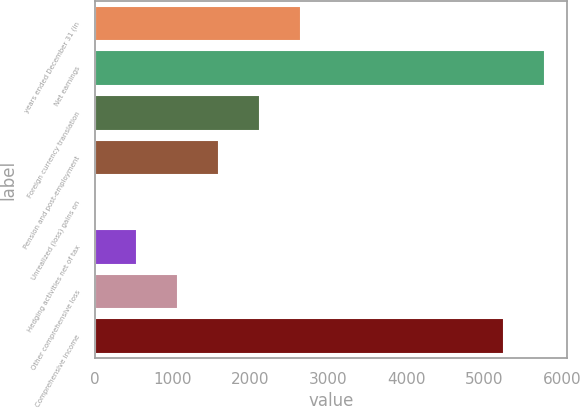Convert chart. <chart><loc_0><loc_0><loc_500><loc_500><bar_chart><fcel>years ended December 31 (in<fcel>Net earnings<fcel>Foreign currency translation<fcel>Pension and post-employment<fcel>Unrealized (loss) gains on<fcel>Hedging activities net of tax<fcel>Other comprehensive loss<fcel>Comprehensive income<nl><fcel>2650<fcel>5771<fcel>2125<fcel>1600<fcel>25<fcel>550<fcel>1075<fcel>5246<nl></chart> 